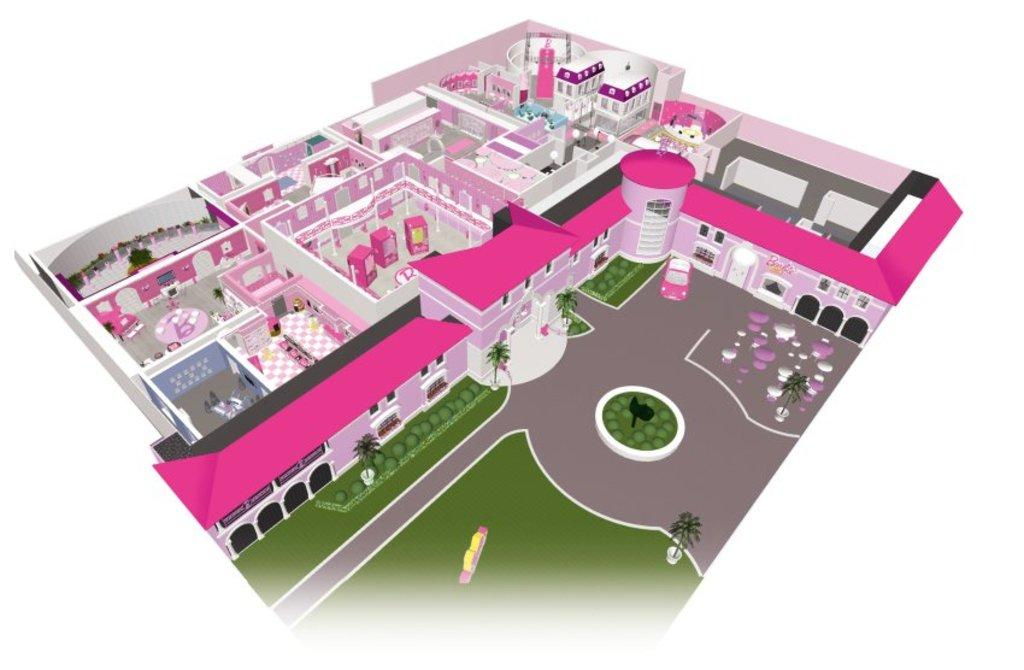What type of image is being described? The image is an animation. What structure can be seen in the image? There is a building in the image. What type of natural elements are present in the image? There are trees in the image. What causes the heart to beat faster in the image? There is no heart present in the image, as it is an animation featuring a building and trees. 